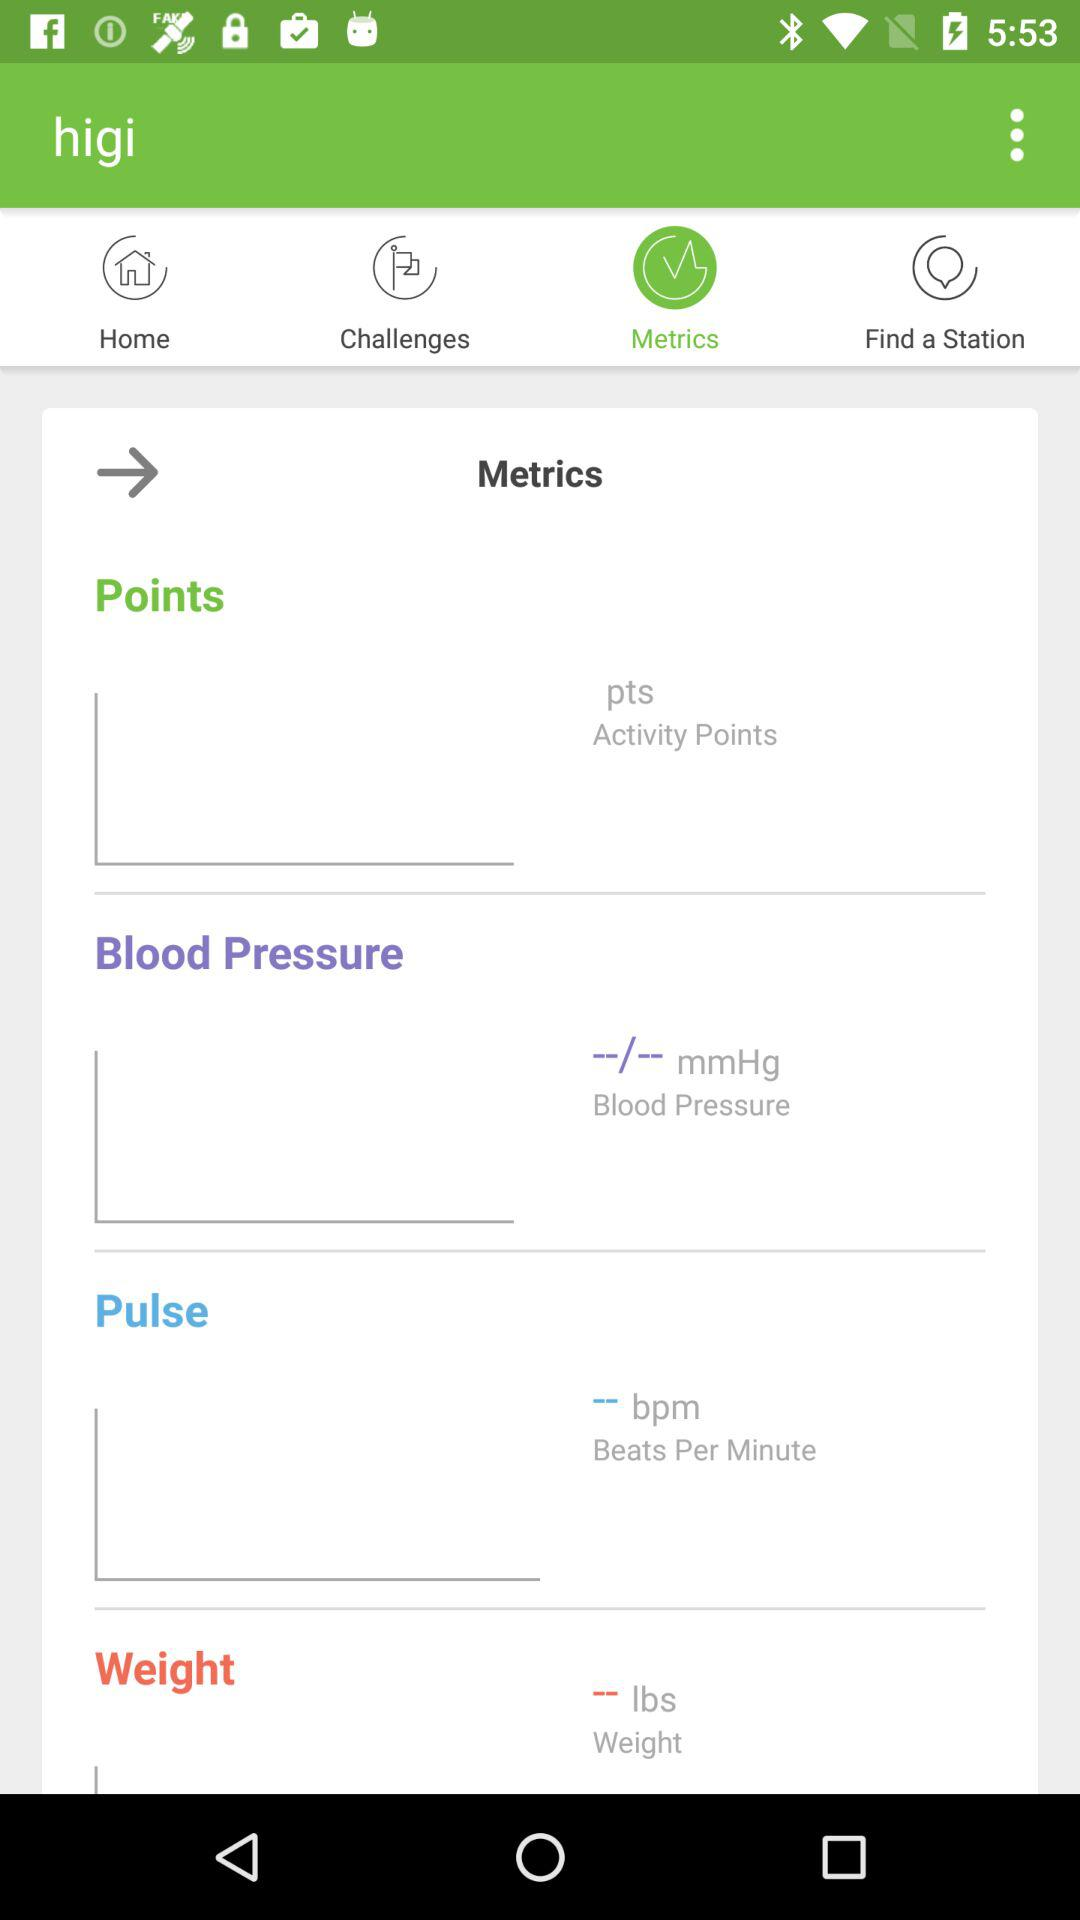How many metrics are displayed in the Metrics section?
Answer the question using a single word or phrase. 4 